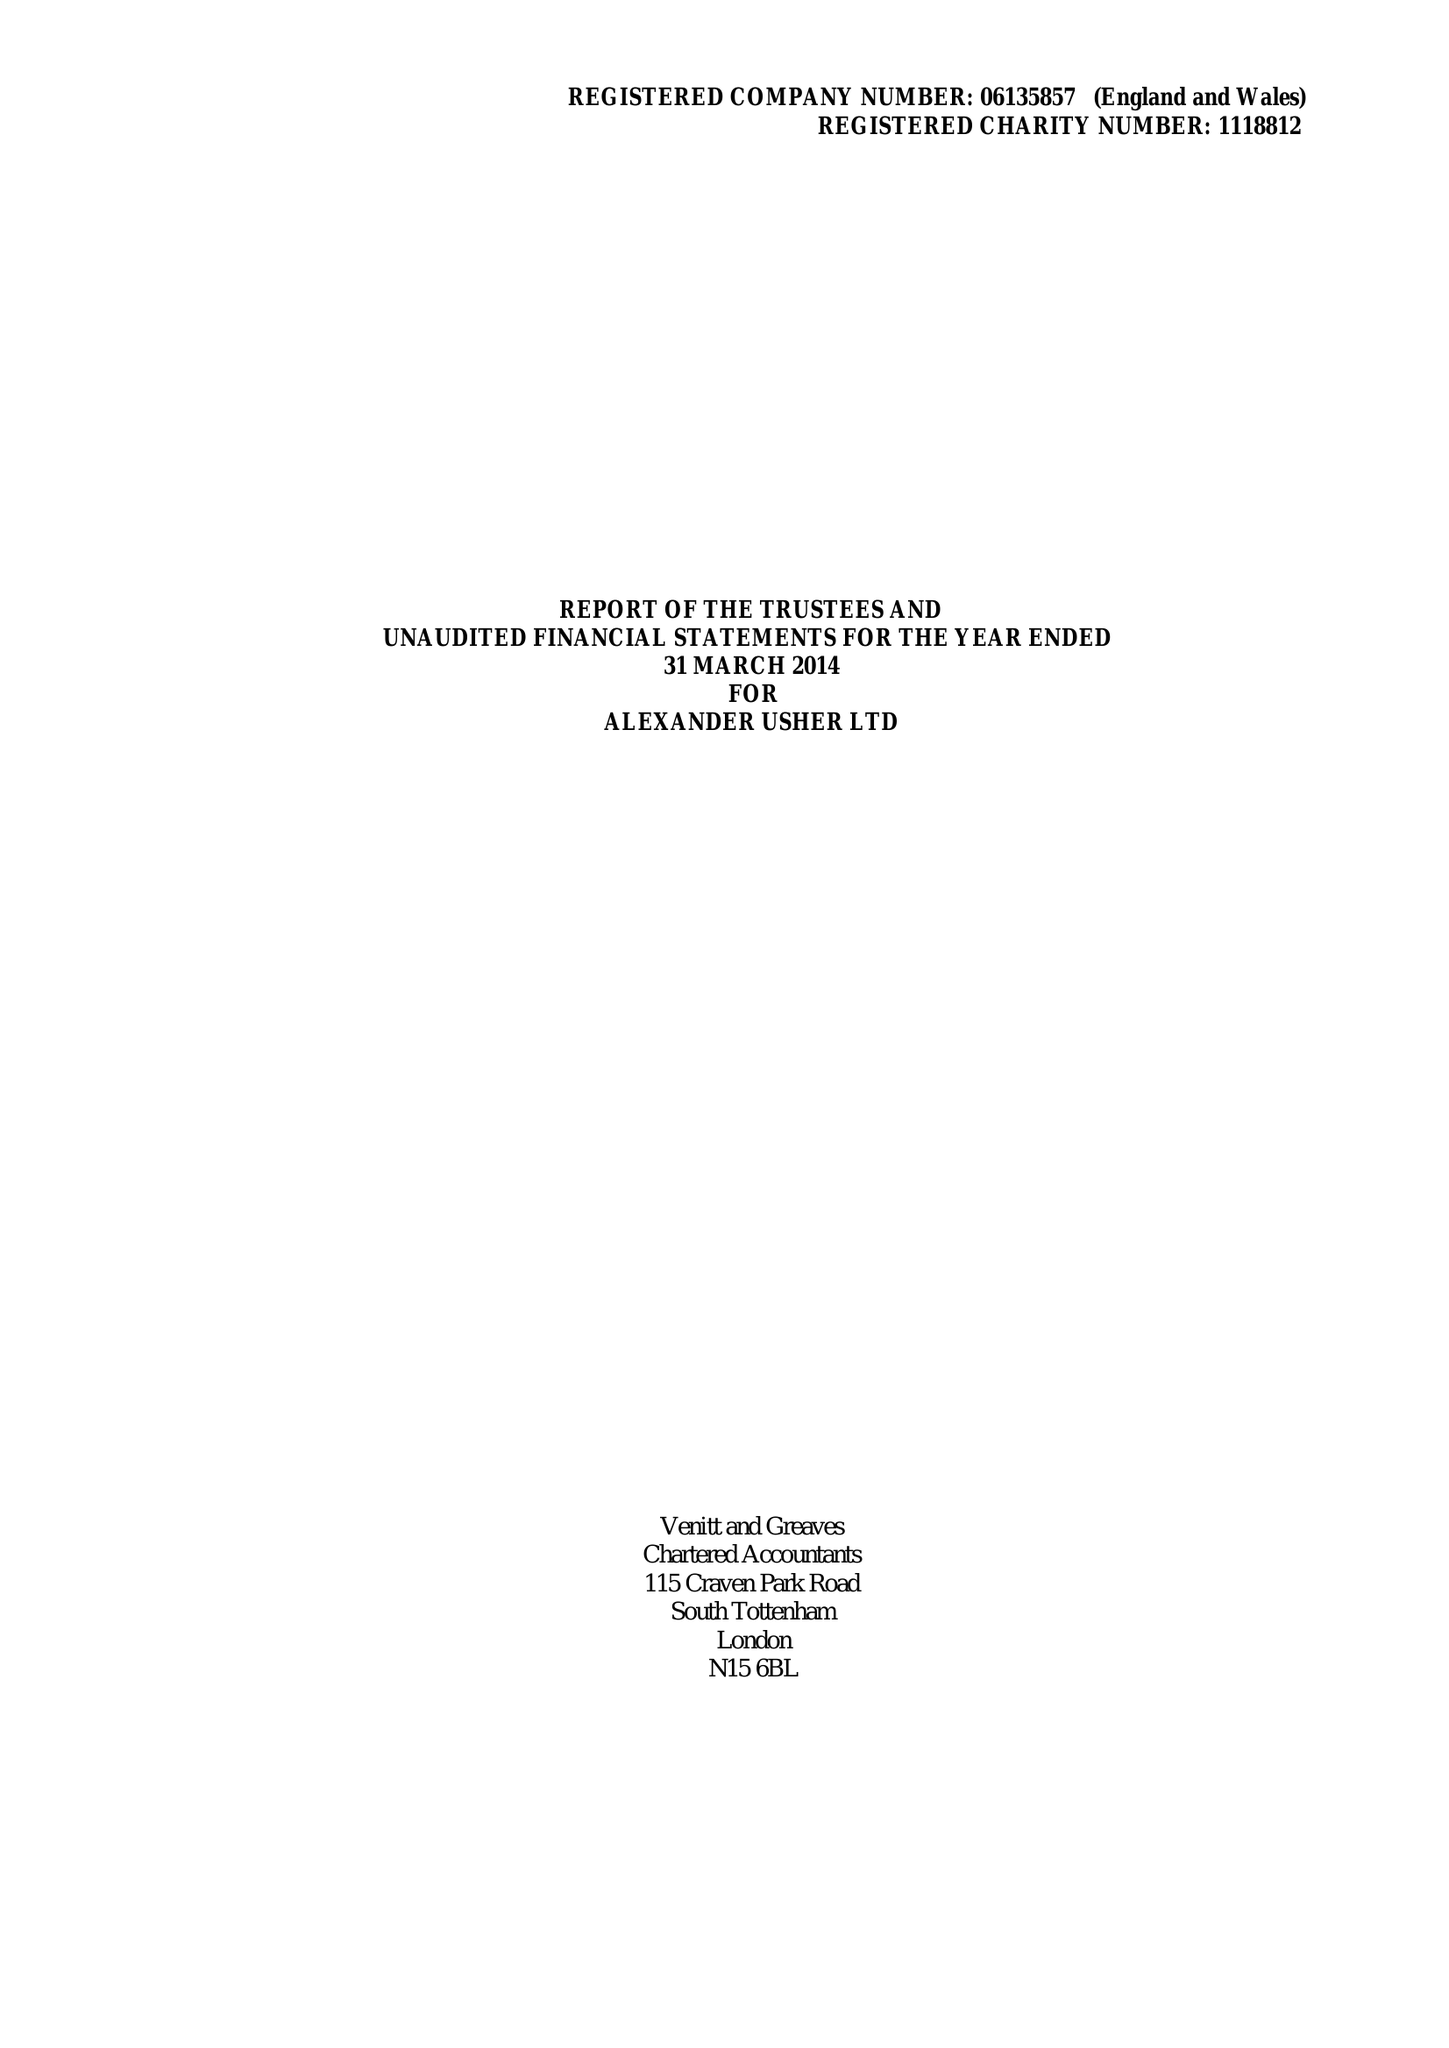What is the value for the spending_annually_in_british_pounds?
Answer the question using a single word or phrase. 247919.00 